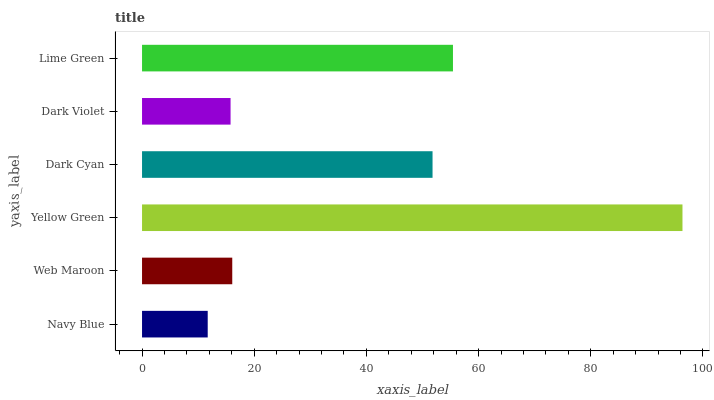Is Navy Blue the minimum?
Answer yes or no. Yes. Is Yellow Green the maximum?
Answer yes or no. Yes. Is Web Maroon the minimum?
Answer yes or no. No. Is Web Maroon the maximum?
Answer yes or no. No. Is Web Maroon greater than Navy Blue?
Answer yes or no. Yes. Is Navy Blue less than Web Maroon?
Answer yes or no. Yes. Is Navy Blue greater than Web Maroon?
Answer yes or no. No. Is Web Maroon less than Navy Blue?
Answer yes or no. No. Is Dark Cyan the high median?
Answer yes or no. Yes. Is Web Maroon the low median?
Answer yes or no. Yes. Is Navy Blue the high median?
Answer yes or no. No. Is Dark Violet the low median?
Answer yes or no. No. 